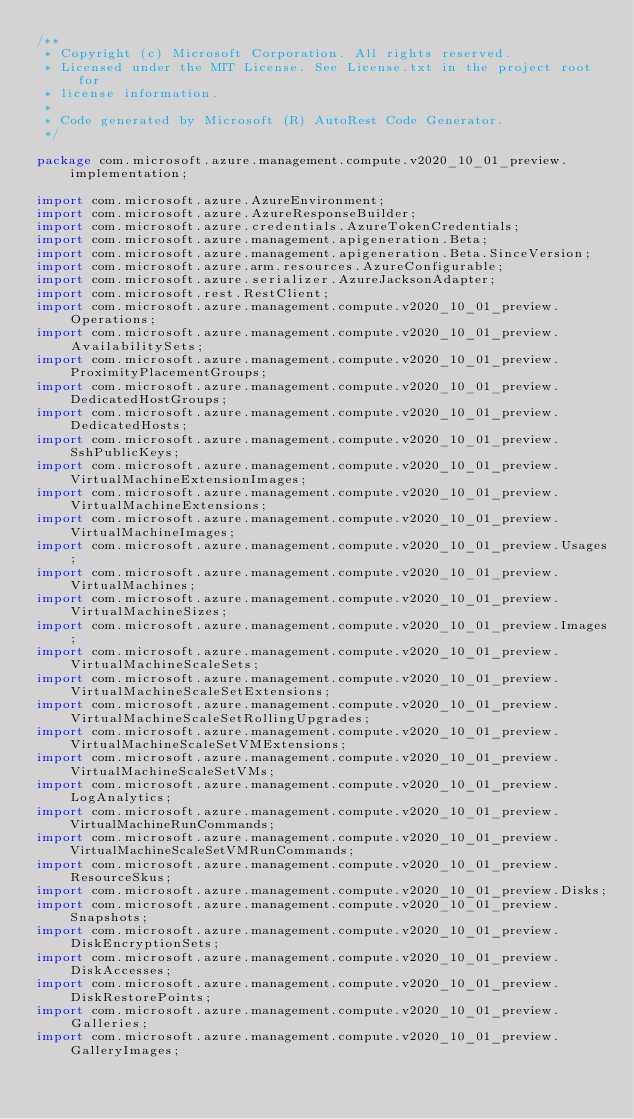<code> <loc_0><loc_0><loc_500><loc_500><_Java_>/**
 * Copyright (c) Microsoft Corporation. All rights reserved.
 * Licensed under the MIT License. See License.txt in the project root for
 * license information.
 *
 * Code generated by Microsoft (R) AutoRest Code Generator.
 */

package com.microsoft.azure.management.compute.v2020_10_01_preview.implementation;

import com.microsoft.azure.AzureEnvironment;
import com.microsoft.azure.AzureResponseBuilder;
import com.microsoft.azure.credentials.AzureTokenCredentials;
import com.microsoft.azure.management.apigeneration.Beta;
import com.microsoft.azure.management.apigeneration.Beta.SinceVersion;
import com.microsoft.azure.arm.resources.AzureConfigurable;
import com.microsoft.azure.serializer.AzureJacksonAdapter;
import com.microsoft.rest.RestClient;
import com.microsoft.azure.management.compute.v2020_10_01_preview.Operations;
import com.microsoft.azure.management.compute.v2020_10_01_preview.AvailabilitySets;
import com.microsoft.azure.management.compute.v2020_10_01_preview.ProximityPlacementGroups;
import com.microsoft.azure.management.compute.v2020_10_01_preview.DedicatedHostGroups;
import com.microsoft.azure.management.compute.v2020_10_01_preview.DedicatedHosts;
import com.microsoft.azure.management.compute.v2020_10_01_preview.SshPublicKeys;
import com.microsoft.azure.management.compute.v2020_10_01_preview.VirtualMachineExtensionImages;
import com.microsoft.azure.management.compute.v2020_10_01_preview.VirtualMachineExtensions;
import com.microsoft.azure.management.compute.v2020_10_01_preview.VirtualMachineImages;
import com.microsoft.azure.management.compute.v2020_10_01_preview.Usages;
import com.microsoft.azure.management.compute.v2020_10_01_preview.VirtualMachines;
import com.microsoft.azure.management.compute.v2020_10_01_preview.VirtualMachineSizes;
import com.microsoft.azure.management.compute.v2020_10_01_preview.Images;
import com.microsoft.azure.management.compute.v2020_10_01_preview.VirtualMachineScaleSets;
import com.microsoft.azure.management.compute.v2020_10_01_preview.VirtualMachineScaleSetExtensions;
import com.microsoft.azure.management.compute.v2020_10_01_preview.VirtualMachineScaleSetRollingUpgrades;
import com.microsoft.azure.management.compute.v2020_10_01_preview.VirtualMachineScaleSetVMExtensions;
import com.microsoft.azure.management.compute.v2020_10_01_preview.VirtualMachineScaleSetVMs;
import com.microsoft.azure.management.compute.v2020_10_01_preview.LogAnalytics;
import com.microsoft.azure.management.compute.v2020_10_01_preview.VirtualMachineRunCommands;
import com.microsoft.azure.management.compute.v2020_10_01_preview.VirtualMachineScaleSetVMRunCommands;
import com.microsoft.azure.management.compute.v2020_10_01_preview.ResourceSkus;
import com.microsoft.azure.management.compute.v2020_10_01_preview.Disks;
import com.microsoft.azure.management.compute.v2020_10_01_preview.Snapshots;
import com.microsoft.azure.management.compute.v2020_10_01_preview.DiskEncryptionSets;
import com.microsoft.azure.management.compute.v2020_10_01_preview.DiskAccesses;
import com.microsoft.azure.management.compute.v2020_10_01_preview.DiskRestorePoints;
import com.microsoft.azure.management.compute.v2020_10_01_preview.Galleries;
import com.microsoft.azure.management.compute.v2020_10_01_preview.GalleryImages;</code> 